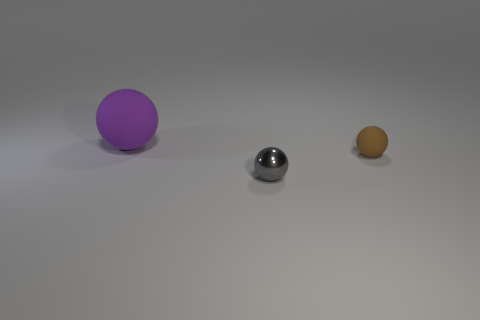Subtract all purple rubber balls. How many balls are left? 2 Add 2 big purple rubber objects. How many objects exist? 5 Subtract all purple balls. How many balls are left? 2 Subtract all blue blocks. How many red spheres are left? 0 Subtract all small gray spheres. Subtract all tiny gray balls. How many objects are left? 1 Add 3 large rubber things. How many large rubber things are left? 4 Add 3 small purple shiny balls. How many small purple shiny balls exist? 3 Subtract 0 blue balls. How many objects are left? 3 Subtract 3 balls. How many balls are left? 0 Subtract all gray spheres. Subtract all brown cylinders. How many spheres are left? 2 